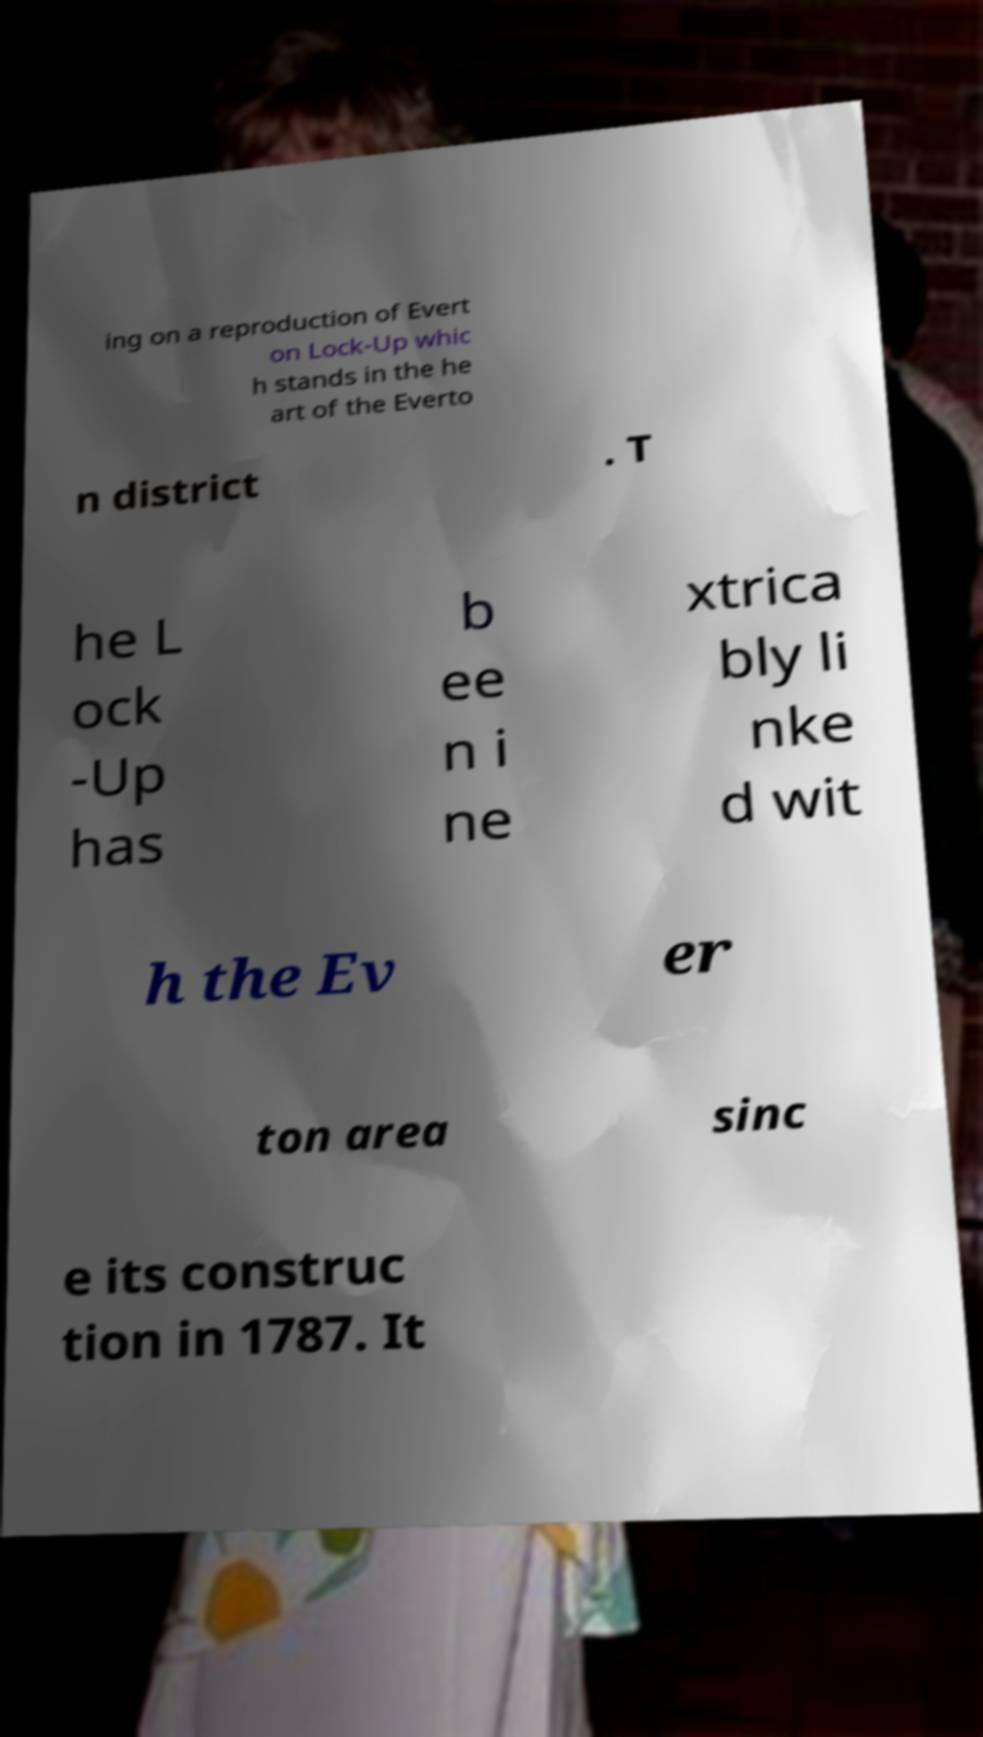Please read and relay the text visible in this image. What does it say? ing on a reproduction of Evert on Lock-Up whic h stands in the he art of the Everto n district . T he L ock -Up has b ee n i ne xtrica bly li nke d wit h the Ev er ton area sinc e its construc tion in 1787. It 